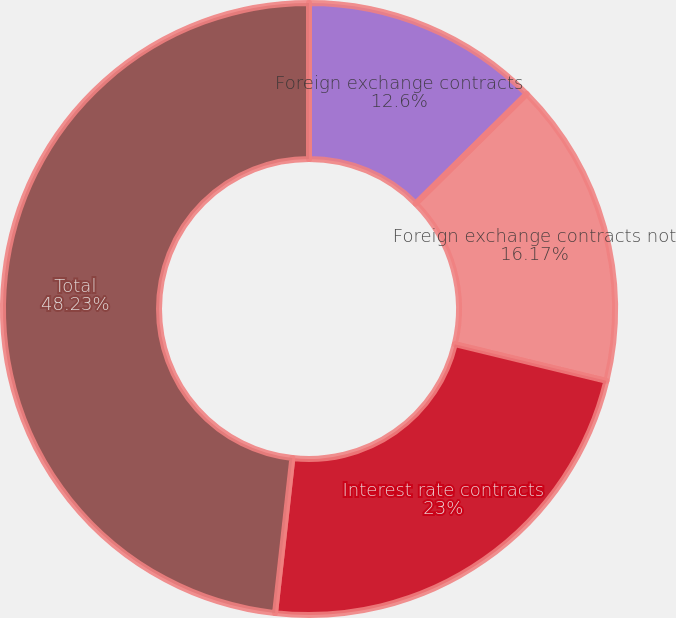<chart> <loc_0><loc_0><loc_500><loc_500><pie_chart><fcel>Foreign exchange contracts<fcel>Foreign exchange contracts not<fcel>Interest rate contracts<fcel>Total<nl><fcel>12.6%<fcel>16.17%<fcel>23.0%<fcel>48.23%<nl></chart> 